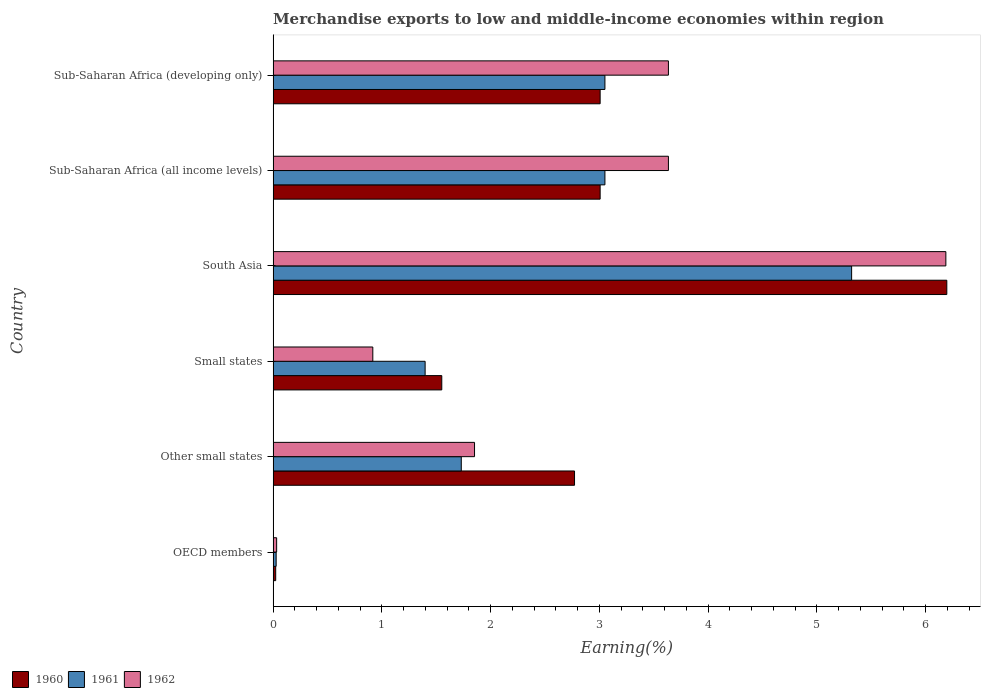How many groups of bars are there?
Offer a very short reply. 6. Are the number of bars on each tick of the Y-axis equal?
Ensure brevity in your answer.  Yes. How many bars are there on the 6th tick from the top?
Your answer should be very brief. 3. What is the label of the 3rd group of bars from the top?
Your answer should be very brief. South Asia. In how many cases, is the number of bars for a given country not equal to the number of legend labels?
Your answer should be very brief. 0. What is the percentage of amount earned from merchandise exports in 1962 in OECD members?
Your answer should be compact. 0.03. Across all countries, what is the maximum percentage of amount earned from merchandise exports in 1960?
Offer a very short reply. 6.19. Across all countries, what is the minimum percentage of amount earned from merchandise exports in 1960?
Keep it short and to the point. 0.02. What is the total percentage of amount earned from merchandise exports in 1962 in the graph?
Provide a short and direct response. 16.26. What is the difference between the percentage of amount earned from merchandise exports in 1960 in OECD members and that in Other small states?
Your answer should be very brief. -2.75. What is the difference between the percentage of amount earned from merchandise exports in 1960 in South Asia and the percentage of amount earned from merchandise exports in 1962 in OECD members?
Offer a very short reply. 6.16. What is the average percentage of amount earned from merchandise exports in 1961 per country?
Your answer should be compact. 2.43. What is the difference between the percentage of amount earned from merchandise exports in 1962 and percentage of amount earned from merchandise exports in 1961 in OECD members?
Your response must be concise. 0. Is the percentage of amount earned from merchandise exports in 1961 in OECD members less than that in Sub-Saharan Africa (developing only)?
Your answer should be very brief. Yes. Is the difference between the percentage of amount earned from merchandise exports in 1962 in Other small states and Sub-Saharan Africa (developing only) greater than the difference between the percentage of amount earned from merchandise exports in 1961 in Other small states and Sub-Saharan Africa (developing only)?
Your answer should be very brief. No. What is the difference between the highest and the second highest percentage of amount earned from merchandise exports in 1961?
Give a very brief answer. 2.27. What is the difference between the highest and the lowest percentage of amount earned from merchandise exports in 1961?
Keep it short and to the point. 5.29. Is the sum of the percentage of amount earned from merchandise exports in 1962 in Small states and Sub-Saharan Africa (developing only) greater than the maximum percentage of amount earned from merchandise exports in 1961 across all countries?
Make the answer very short. No. What does the 3rd bar from the bottom in OECD members represents?
Offer a terse response. 1962. Is it the case that in every country, the sum of the percentage of amount earned from merchandise exports in 1960 and percentage of amount earned from merchandise exports in 1962 is greater than the percentage of amount earned from merchandise exports in 1961?
Offer a terse response. Yes. How many bars are there?
Your answer should be very brief. 18. Are all the bars in the graph horizontal?
Provide a succinct answer. Yes. Are the values on the major ticks of X-axis written in scientific E-notation?
Ensure brevity in your answer.  No. Does the graph contain grids?
Keep it short and to the point. No. How are the legend labels stacked?
Provide a succinct answer. Horizontal. What is the title of the graph?
Make the answer very short. Merchandise exports to low and middle-income economies within region. What is the label or title of the X-axis?
Your answer should be very brief. Earning(%). What is the Earning(%) in 1960 in OECD members?
Keep it short and to the point. 0.02. What is the Earning(%) in 1961 in OECD members?
Ensure brevity in your answer.  0.03. What is the Earning(%) of 1962 in OECD members?
Your response must be concise. 0.03. What is the Earning(%) in 1960 in Other small states?
Provide a short and direct response. 2.77. What is the Earning(%) of 1961 in Other small states?
Offer a very short reply. 1.73. What is the Earning(%) in 1962 in Other small states?
Your answer should be compact. 1.85. What is the Earning(%) in 1960 in Small states?
Provide a succinct answer. 1.55. What is the Earning(%) of 1961 in Small states?
Keep it short and to the point. 1.4. What is the Earning(%) in 1962 in Small states?
Your answer should be very brief. 0.92. What is the Earning(%) in 1960 in South Asia?
Your answer should be compact. 6.19. What is the Earning(%) of 1961 in South Asia?
Keep it short and to the point. 5.32. What is the Earning(%) of 1962 in South Asia?
Provide a succinct answer. 6.19. What is the Earning(%) in 1960 in Sub-Saharan Africa (all income levels)?
Provide a short and direct response. 3.01. What is the Earning(%) of 1961 in Sub-Saharan Africa (all income levels)?
Offer a terse response. 3.05. What is the Earning(%) in 1962 in Sub-Saharan Africa (all income levels)?
Your answer should be very brief. 3.63. What is the Earning(%) of 1960 in Sub-Saharan Africa (developing only)?
Offer a terse response. 3.01. What is the Earning(%) of 1961 in Sub-Saharan Africa (developing only)?
Ensure brevity in your answer.  3.05. What is the Earning(%) in 1962 in Sub-Saharan Africa (developing only)?
Offer a terse response. 3.63. Across all countries, what is the maximum Earning(%) in 1960?
Offer a terse response. 6.19. Across all countries, what is the maximum Earning(%) of 1961?
Offer a very short reply. 5.32. Across all countries, what is the maximum Earning(%) of 1962?
Provide a short and direct response. 6.19. Across all countries, what is the minimum Earning(%) of 1960?
Your answer should be very brief. 0.02. Across all countries, what is the minimum Earning(%) of 1961?
Ensure brevity in your answer.  0.03. Across all countries, what is the minimum Earning(%) in 1962?
Your answer should be compact. 0.03. What is the total Earning(%) in 1960 in the graph?
Give a very brief answer. 16.55. What is the total Earning(%) in 1961 in the graph?
Your answer should be compact. 14.58. What is the total Earning(%) in 1962 in the graph?
Your response must be concise. 16.26. What is the difference between the Earning(%) of 1960 in OECD members and that in Other small states?
Offer a terse response. -2.75. What is the difference between the Earning(%) of 1961 in OECD members and that in Other small states?
Provide a short and direct response. -1.7. What is the difference between the Earning(%) of 1962 in OECD members and that in Other small states?
Provide a short and direct response. -1.82. What is the difference between the Earning(%) in 1960 in OECD members and that in Small states?
Provide a short and direct response. -1.53. What is the difference between the Earning(%) in 1961 in OECD members and that in Small states?
Your response must be concise. -1.37. What is the difference between the Earning(%) in 1962 in OECD members and that in Small states?
Ensure brevity in your answer.  -0.88. What is the difference between the Earning(%) of 1960 in OECD members and that in South Asia?
Your answer should be very brief. -6.17. What is the difference between the Earning(%) in 1961 in OECD members and that in South Asia?
Your answer should be very brief. -5.29. What is the difference between the Earning(%) of 1962 in OECD members and that in South Asia?
Your response must be concise. -6.15. What is the difference between the Earning(%) of 1960 in OECD members and that in Sub-Saharan Africa (all income levels)?
Provide a succinct answer. -2.98. What is the difference between the Earning(%) in 1961 in OECD members and that in Sub-Saharan Africa (all income levels)?
Ensure brevity in your answer.  -3.02. What is the difference between the Earning(%) in 1962 in OECD members and that in Sub-Saharan Africa (all income levels)?
Offer a terse response. -3.6. What is the difference between the Earning(%) of 1960 in OECD members and that in Sub-Saharan Africa (developing only)?
Your response must be concise. -2.98. What is the difference between the Earning(%) in 1961 in OECD members and that in Sub-Saharan Africa (developing only)?
Provide a succinct answer. -3.02. What is the difference between the Earning(%) in 1962 in OECD members and that in Sub-Saharan Africa (developing only)?
Provide a short and direct response. -3.6. What is the difference between the Earning(%) of 1960 in Other small states and that in Small states?
Your response must be concise. 1.22. What is the difference between the Earning(%) in 1961 in Other small states and that in Small states?
Offer a very short reply. 0.33. What is the difference between the Earning(%) of 1962 in Other small states and that in Small states?
Give a very brief answer. 0.94. What is the difference between the Earning(%) of 1960 in Other small states and that in South Asia?
Provide a short and direct response. -3.42. What is the difference between the Earning(%) of 1961 in Other small states and that in South Asia?
Give a very brief answer. -3.59. What is the difference between the Earning(%) in 1962 in Other small states and that in South Asia?
Your answer should be very brief. -4.33. What is the difference between the Earning(%) in 1960 in Other small states and that in Sub-Saharan Africa (all income levels)?
Your response must be concise. -0.24. What is the difference between the Earning(%) of 1961 in Other small states and that in Sub-Saharan Africa (all income levels)?
Your answer should be compact. -1.32. What is the difference between the Earning(%) of 1962 in Other small states and that in Sub-Saharan Africa (all income levels)?
Make the answer very short. -1.78. What is the difference between the Earning(%) in 1960 in Other small states and that in Sub-Saharan Africa (developing only)?
Make the answer very short. -0.24. What is the difference between the Earning(%) of 1961 in Other small states and that in Sub-Saharan Africa (developing only)?
Offer a very short reply. -1.32. What is the difference between the Earning(%) of 1962 in Other small states and that in Sub-Saharan Africa (developing only)?
Offer a very short reply. -1.78. What is the difference between the Earning(%) of 1960 in Small states and that in South Asia?
Your response must be concise. -4.64. What is the difference between the Earning(%) in 1961 in Small states and that in South Asia?
Provide a short and direct response. -3.92. What is the difference between the Earning(%) in 1962 in Small states and that in South Asia?
Ensure brevity in your answer.  -5.27. What is the difference between the Earning(%) of 1960 in Small states and that in Sub-Saharan Africa (all income levels)?
Offer a terse response. -1.46. What is the difference between the Earning(%) of 1961 in Small states and that in Sub-Saharan Africa (all income levels)?
Provide a succinct answer. -1.65. What is the difference between the Earning(%) of 1962 in Small states and that in Sub-Saharan Africa (all income levels)?
Your answer should be compact. -2.72. What is the difference between the Earning(%) in 1960 in Small states and that in Sub-Saharan Africa (developing only)?
Make the answer very short. -1.46. What is the difference between the Earning(%) in 1961 in Small states and that in Sub-Saharan Africa (developing only)?
Your answer should be very brief. -1.65. What is the difference between the Earning(%) in 1962 in Small states and that in Sub-Saharan Africa (developing only)?
Keep it short and to the point. -2.72. What is the difference between the Earning(%) of 1960 in South Asia and that in Sub-Saharan Africa (all income levels)?
Make the answer very short. 3.19. What is the difference between the Earning(%) in 1961 in South Asia and that in Sub-Saharan Africa (all income levels)?
Provide a succinct answer. 2.27. What is the difference between the Earning(%) of 1962 in South Asia and that in Sub-Saharan Africa (all income levels)?
Ensure brevity in your answer.  2.55. What is the difference between the Earning(%) in 1960 in South Asia and that in Sub-Saharan Africa (developing only)?
Keep it short and to the point. 3.19. What is the difference between the Earning(%) of 1961 in South Asia and that in Sub-Saharan Africa (developing only)?
Make the answer very short. 2.27. What is the difference between the Earning(%) in 1962 in South Asia and that in Sub-Saharan Africa (developing only)?
Offer a very short reply. 2.55. What is the difference between the Earning(%) of 1961 in Sub-Saharan Africa (all income levels) and that in Sub-Saharan Africa (developing only)?
Make the answer very short. 0. What is the difference between the Earning(%) of 1962 in Sub-Saharan Africa (all income levels) and that in Sub-Saharan Africa (developing only)?
Your answer should be compact. 0. What is the difference between the Earning(%) in 1960 in OECD members and the Earning(%) in 1961 in Other small states?
Your answer should be very brief. -1.71. What is the difference between the Earning(%) in 1960 in OECD members and the Earning(%) in 1962 in Other small states?
Your answer should be very brief. -1.83. What is the difference between the Earning(%) of 1961 in OECD members and the Earning(%) of 1962 in Other small states?
Offer a terse response. -1.82. What is the difference between the Earning(%) of 1960 in OECD members and the Earning(%) of 1961 in Small states?
Offer a terse response. -1.37. What is the difference between the Earning(%) of 1960 in OECD members and the Earning(%) of 1962 in Small states?
Provide a succinct answer. -0.89. What is the difference between the Earning(%) of 1961 in OECD members and the Earning(%) of 1962 in Small states?
Offer a very short reply. -0.89. What is the difference between the Earning(%) in 1960 in OECD members and the Earning(%) in 1961 in South Asia?
Your response must be concise. -5.3. What is the difference between the Earning(%) of 1960 in OECD members and the Earning(%) of 1962 in South Asia?
Provide a short and direct response. -6.16. What is the difference between the Earning(%) of 1961 in OECD members and the Earning(%) of 1962 in South Asia?
Give a very brief answer. -6.16. What is the difference between the Earning(%) of 1960 in OECD members and the Earning(%) of 1961 in Sub-Saharan Africa (all income levels)?
Give a very brief answer. -3.03. What is the difference between the Earning(%) in 1960 in OECD members and the Earning(%) in 1962 in Sub-Saharan Africa (all income levels)?
Offer a very short reply. -3.61. What is the difference between the Earning(%) in 1961 in OECD members and the Earning(%) in 1962 in Sub-Saharan Africa (all income levels)?
Offer a terse response. -3.61. What is the difference between the Earning(%) of 1960 in OECD members and the Earning(%) of 1961 in Sub-Saharan Africa (developing only)?
Offer a terse response. -3.03. What is the difference between the Earning(%) in 1960 in OECD members and the Earning(%) in 1962 in Sub-Saharan Africa (developing only)?
Keep it short and to the point. -3.61. What is the difference between the Earning(%) of 1961 in OECD members and the Earning(%) of 1962 in Sub-Saharan Africa (developing only)?
Your answer should be compact. -3.61. What is the difference between the Earning(%) in 1960 in Other small states and the Earning(%) in 1961 in Small states?
Ensure brevity in your answer.  1.37. What is the difference between the Earning(%) in 1960 in Other small states and the Earning(%) in 1962 in Small states?
Offer a terse response. 1.85. What is the difference between the Earning(%) of 1961 in Other small states and the Earning(%) of 1962 in Small states?
Make the answer very short. 0.81. What is the difference between the Earning(%) in 1960 in Other small states and the Earning(%) in 1961 in South Asia?
Make the answer very short. -2.55. What is the difference between the Earning(%) of 1960 in Other small states and the Earning(%) of 1962 in South Asia?
Give a very brief answer. -3.41. What is the difference between the Earning(%) in 1961 in Other small states and the Earning(%) in 1962 in South Asia?
Your response must be concise. -4.46. What is the difference between the Earning(%) in 1960 in Other small states and the Earning(%) in 1961 in Sub-Saharan Africa (all income levels)?
Keep it short and to the point. -0.28. What is the difference between the Earning(%) in 1960 in Other small states and the Earning(%) in 1962 in Sub-Saharan Africa (all income levels)?
Keep it short and to the point. -0.86. What is the difference between the Earning(%) of 1961 in Other small states and the Earning(%) of 1962 in Sub-Saharan Africa (all income levels)?
Provide a succinct answer. -1.9. What is the difference between the Earning(%) of 1960 in Other small states and the Earning(%) of 1961 in Sub-Saharan Africa (developing only)?
Your response must be concise. -0.28. What is the difference between the Earning(%) of 1960 in Other small states and the Earning(%) of 1962 in Sub-Saharan Africa (developing only)?
Give a very brief answer. -0.86. What is the difference between the Earning(%) of 1961 in Other small states and the Earning(%) of 1962 in Sub-Saharan Africa (developing only)?
Offer a very short reply. -1.9. What is the difference between the Earning(%) of 1960 in Small states and the Earning(%) of 1961 in South Asia?
Your answer should be very brief. -3.77. What is the difference between the Earning(%) of 1960 in Small states and the Earning(%) of 1962 in South Asia?
Make the answer very short. -4.63. What is the difference between the Earning(%) in 1961 in Small states and the Earning(%) in 1962 in South Asia?
Provide a succinct answer. -4.79. What is the difference between the Earning(%) of 1960 in Small states and the Earning(%) of 1961 in Sub-Saharan Africa (all income levels)?
Your answer should be compact. -1.5. What is the difference between the Earning(%) in 1960 in Small states and the Earning(%) in 1962 in Sub-Saharan Africa (all income levels)?
Provide a short and direct response. -2.08. What is the difference between the Earning(%) in 1961 in Small states and the Earning(%) in 1962 in Sub-Saharan Africa (all income levels)?
Provide a short and direct response. -2.24. What is the difference between the Earning(%) in 1960 in Small states and the Earning(%) in 1961 in Sub-Saharan Africa (developing only)?
Ensure brevity in your answer.  -1.5. What is the difference between the Earning(%) in 1960 in Small states and the Earning(%) in 1962 in Sub-Saharan Africa (developing only)?
Offer a terse response. -2.08. What is the difference between the Earning(%) of 1961 in Small states and the Earning(%) of 1962 in Sub-Saharan Africa (developing only)?
Give a very brief answer. -2.24. What is the difference between the Earning(%) of 1960 in South Asia and the Earning(%) of 1961 in Sub-Saharan Africa (all income levels)?
Your answer should be very brief. 3.14. What is the difference between the Earning(%) in 1960 in South Asia and the Earning(%) in 1962 in Sub-Saharan Africa (all income levels)?
Your answer should be very brief. 2.56. What is the difference between the Earning(%) in 1961 in South Asia and the Earning(%) in 1962 in Sub-Saharan Africa (all income levels)?
Make the answer very short. 1.68. What is the difference between the Earning(%) in 1960 in South Asia and the Earning(%) in 1961 in Sub-Saharan Africa (developing only)?
Offer a terse response. 3.14. What is the difference between the Earning(%) in 1960 in South Asia and the Earning(%) in 1962 in Sub-Saharan Africa (developing only)?
Keep it short and to the point. 2.56. What is the difference between the Earning(%) in 1961 in South Asia and the Earning(%) in 1962 in Sub-Saharan Africa (developing only)?
Offer a terse response. 1.68. What is the difference between the Earning(%) of 1960 in Sub-Saharan Africa (all income levels) and the Earning(%) of 1961 in Sub-Saharan Africa (developing only)?
Your response must be concise. -0.04. What is the difference between the Earning(%) in 1960 in Sub-Saharan Africa (all income levels) and the Earning(%) in 1962 in Sub-Saharan Africa (developing only)?
Offer a very short reply. -0.63. What is the difference between the Earning(%) of 1961 in Sub-Saharan Africa (all income levels) and the Earning(%) of 1962 in Sub-Saharan Africa (developing only)?
Keep it short and to the point. -0.58. What is the average Earning(%) of 1960 per country?
Make the answer very short. 2.76. What is the average Earning(%) of 1961 per country?
Provide a short and direct response. 2.43. What is the average Earning(%) of 1962 per country?
Offer a very short reply. 2.71. What is the difference between the Earning(%) in 1960 and Earning(%) in 1961 in OECD members?
Your answer should be compact. -0. What is the difference between the Earning(%) of 1960 and Earning(%) of 1962 in OECD members?
Offer a terse response. -0.01. What is the difference between the Earning(%) of 1961 and Earning(%) of 1962 in OECD members?
Provide a succinct answer. -0. What is the difference between the Earning(%) of 1960 and Earning(%) of 1961 in Other small states?
Provide a short and direct response. 1.04. What is the difference between the Earning(%) of 1960 and Earning(%) of 1962 in Other small states?
Make the answer very short. 0.92. What is the difference between the Earning(%) of 1961 and Earning(%) of 1962 in Other small states?
Offer a very short reply. -0.12. What is the difference between the Earning(%) of 1960 and Earning(%) of 1961 in Small states?
Offer a very short reply. 0.15. What is the difference between the Earning(%) of 1960 and Earning(%) of 1962 in Small states?
Your answer should be compact. 0.63. What is the difference between the Earning(%) in 1961 and Earning(%) in 1962 in Small states?
Your answer should be very brief. 0.48. What is the difference between the Earning(%) of 1960 and Earning(%) of 1961 in South Asia?
Offer a very short reply. 0.88. What is the difference between the Earning(%) of 1960 and Earning(%) of 1962 in South Asia?
Provide a succinct answer. 0.01. What is the difference between the Earning(%) in 1961 and Earning(%) in 1962 in South Asia?
Your answer should be compact. -0.87. What is the difference between the Earning(%) in 1960 and Earning(%) in 1961 in Sub-Saharan Africa (all income levels)?
Your response must be concise. -0.04. What is the difference between the Earning(%) of 1960 and Earning(%) of 1962 in Sub-Saharan Africa (all income levels)?
Provide a short and direct response. -0.63. What is the difference between the Earning(%) in 1961 and Earning(%) in 1962 in Sub-Saharan Africa (all income levels)?
Provide a succinct answer. -0.58. What is the difference between the Earning(%) of 1960 and Earning(%) of 1961 in Sub-Saharan Africa (developing only)?
Provide a succinct answer. -0.04. What is the difference between the Earning(%) in 1960 and Earning(%) in 1962 in Sub-Saharan Africa (developing only)?
Ensure brevity in your answer.  -0.63. What is the difference between the Earning(%) of 1961 and Earning(%) of 1962 in Sub-Saharan Africa (developing only)?
Your response must be concise. -0.58. What is the ratio of the Earning(%) of 1960 in OECD members to that in Other small states?
Your response must be concise. 0.01. What is the ratio of the Earning(%) of 1961 in OECD members to that in Other small states?
Provide a succinct answer. 0.02. What is the ratio of the Earning(%) of 1962 in OECD members to that in Other small states?
Offer a terse response. 0.02. What is the ratio of the Earning(%) of 1960 in OECD members to that in Small states?
Give a very brief answer. 0.02. What is the ratio of the Earning(%) in 1961 in OECD members to that in Small states?
Give a very brief answer. 0.02. What is the ratio of the Earning(%) in 1962 in OECD members to that in Small states?
Offer a terse response. 0.04. What is the ratio of the Earning(%) in 1960 in OECD members to that in South Asia?
Offer a terse response. 0. What is the ratio of the Earning(%) in 1961 in OECD members to that in South Asia?
Keep it short and to the point. 0.01. What is the ratio of the Earning(%) in 1962 in OECD members to that in South Asia?
Provide a short and direct response. 0.01. What is the ratio of the Earning(%) of 1960 in OECD members to that in Sub-Saharan Africa (all income levels)?
Offer a terse response. 0.01. What is the ratio of the Earning(%) in 1961 in OECD members to that in Sub-Saharan Africa (all income levels)?
Your answer should be very brief. 0.01. What is the ratio of the Earning(%) of 1962 in OECD members to that in Sub-Saharan Africa (all income levels)?
Provide a succinct answer. 0.01. What is the ratio of the Earning(%) in 1960 in OECD members to that in Sub-Saharan Africa (developing only)?
Provide a short and direct response. 0.01. What is the ratio of the Earning(%) of 1961 in OECD members to that in Sub-Saharan Africa (developing only)?
Your response must be concise. 0.01. What is the ratio of the Earning(%) of 1962 in OECD members to that in Sub-Saharan Africa (developing only)?
Your answer should be very brief. 0.01. What is the ratio of the Earning(%) in 1960 in Other small states to that in Small states?
Your answer should be very brief. 1.79. What is the ratio of the Earning(%) in 1961 in Other small states to that in Small states?
Your answer should be compact. 1.24. What is the ratio of the Earning(%) in 1962 in Other small states to that in Small states?
Your answer should be very brief. 2.02. What is the ratio of the Earning(%) in 1960 in Other small states to that in South Asia?
Provide a succinct answer. 0.45. What is the ratio of the Earning(%) of 1961 in Other small states to that in South Asia?
Offer a terse response. 0.33. What is the ratio of the Earning(%) in 1962 in Other small states to that in South Asia?
Ensure brevity in your answer.  0.3. What is the ratio of the Earning(%) of 1960 in Other small states to that in Sub-Saharan Africa (all income levels)?
Keep it short and to the point. 0.92. What is the ratio of the Earning(%) of 1961 in Other small states to that in Sub-Saharan Africa (all income levels)?
Your response must be concise. 0.57. What is the ratio of the Earning(%) in 1962 in Other small states to that in Sub-Saharan Africa (all income levels)?
Your answer should be compact. 0.51. What is the ratio of the Earning(%) of 1960 in Other small states to that in Sub-Saharan Africa (developing only)?
Provide a succinct answer. 0.92. What is the ratio of the Earning(%) in 1961 in Other small states to that in Sub-Saharan Africa (developing only)?
Keep it short and to the point. 0.57. What is the ratio of the Earning(%) of 1962 in Other small states to that in Sub-Saharan Africa (developing only)?
Keep it short and to the point. 0.51. What is the ratio of the Earning(%) of 1960 in Small states to that in South Asia?
Keep it short and to the point. 0.25. What is the ratio of the Earning(%) in 1961 in Small states to that in South Asia?
Your answer should be very brief. 0.26. What is the ratio of the Earning(%) in 1962 in Small states to that in South Asia?
Make the answer very short. 0.15. What is the ratio of the Earning(%) in 1960 in Small states to that in Sub-Saharan Africa (all income levels)?
Keep it short and to the point. 0.52. What is the ratio of the Earning(%) in 1961 in Small states to that in Sub-Saharan Africa (all income levels)?
Ensure brevity in your answer.  0.46. What is the ratio of the Earning(%) of 1962 in Small states to that in Sub-Saharan Africa (all income levels)?
Your answer should be compact. 0.25. What is the ratio of the Earning(%) of 1960 in Small states to that in Sub-Saharan Africa (developing only)?
Your answer should be compact. 0.52. What is the ratio of the Earning(%) in 1961 in Small states to that in Sub-Saharan Africa (developing only)?
Keep it short and to the point. 0.46. What is the ratio of the Earning(%) in 1962 in Small states to that in Sub-Saharan Africa (developing only)?
Your answer should be compact. 0.25. What is the ratio of the Earning(%) in 1960 in South Asia to that in Sub-Saharan Africa (all income levels)?
Your response must be concise. 2.06. What is the ratio of the Earning(%) in 1961 in South Asia to that in Sub-Saharan Africa (all income levels)?
Offer a terse response. 1.74. What is the ratio of the Earning(%) of 1962 in South Asia to that in Sub-Saharan Africa (all income levels)?
Keep it short and to the point. 1.7. What is the ratio of the Earning(%) in 1960 in South Asia to that in Sub-Saharan Africa (developing only)?
Your answer should be compact. 2.06. What is the ratio of the Earning(%) of 1961 in South Asia to that in Sub-Saharan Africa (developing only)?
Offer a terse response. 1.74. What is the ratio of the Earning(%) in 1962 in South Asia to that in Sub-Saharan Africa (developing only)?
Offer a terse response. 1.7. What is the ratio of the Earning(%) of 1962 in Sub-Saharan Africa (all income levels) to that in Sub-Saharan Africa (developing only)?
Give a very brief answer. 1. What is the difference between the highest and the second highest Earning(%) of 1960?
Your response must be concise. 3.19. What is the difference between the highest and the second highest Earning(%) of 1961?
Offer a very short reply. 2.27. What is the difference between the highest and the second highest Earning(%) of 1962?
Offer a very short reply. 2.55. What is the difference between the highest and the lowest Earning(%) in 1960?
Provide a succinct answer. 6.17. What is the difference between the highest and the lowest Earning(%) of 1961?
Your answer should be very brief. 5.29. What is the difference between the highest and the lowest Earning(%) of 1962?
Provide a short and direct response. 6.15. 